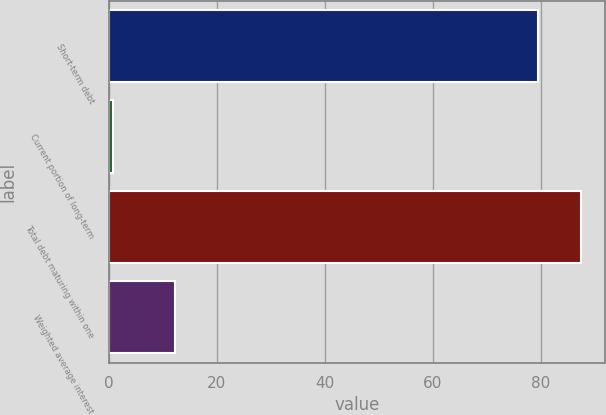<chart> <loc_0><loc_0><loc_500><loc_500><bar_chart><fcel>Short-term debt<fcel>Current portion of long-term<fcel>Total debt maturing within one<fcel>Weighted average interest<nl><fcel>79.5<fcel>0.9<fcel>87.45<fcel>12.2<nl></chart> 